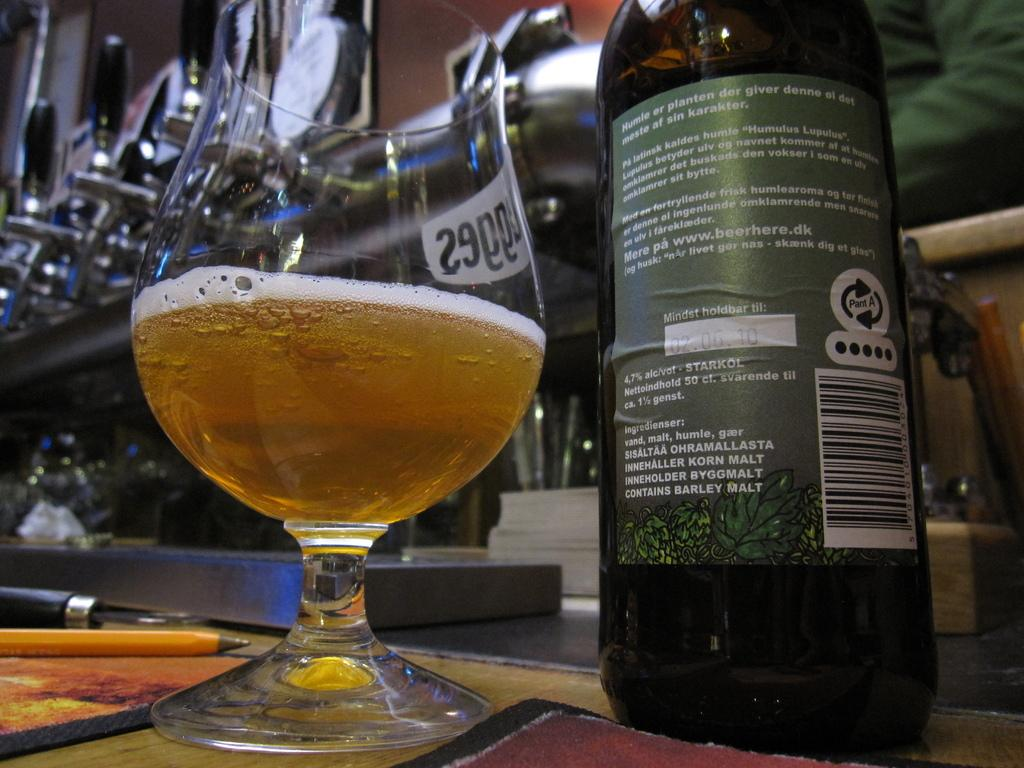What is on the bottle that is visible in the image? There is a sticker on the bottle in the image. What is inside the glass that is visible in the image? There is a drink in the glass in the image. Where are the bottle and glass located in the image? Both the bottle and glass are on a table in the image. What writing instruments are on the table in the image? There is a pencil and a pen on the table in the image. What type of argument is taking place between the bottle and the glass in the image? There is no argument taking place between the bottle and the glass in the image; they are inanimate objects. 